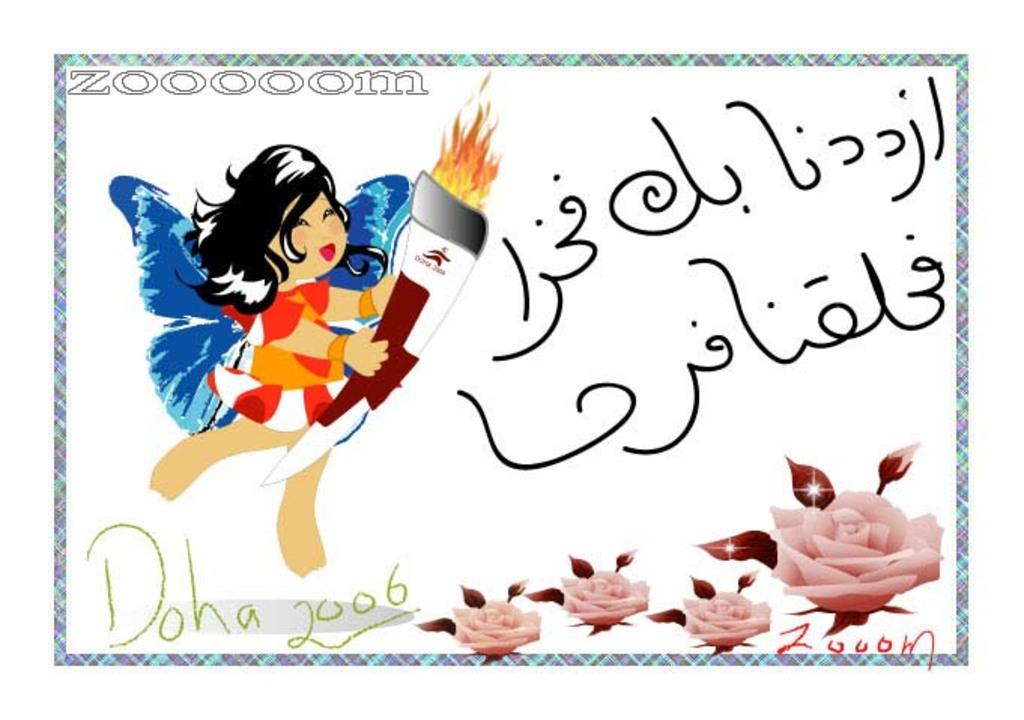What type of image is depicted in the picture? There is a cartoon in the image. What other elements can be seen in the image besides the cartoon? There are flowers and some text in the image. What type of silk is being used to create the jellyfish in the image? There is no silk or jellyfish present in the image; it features a cartoon and flowers. 